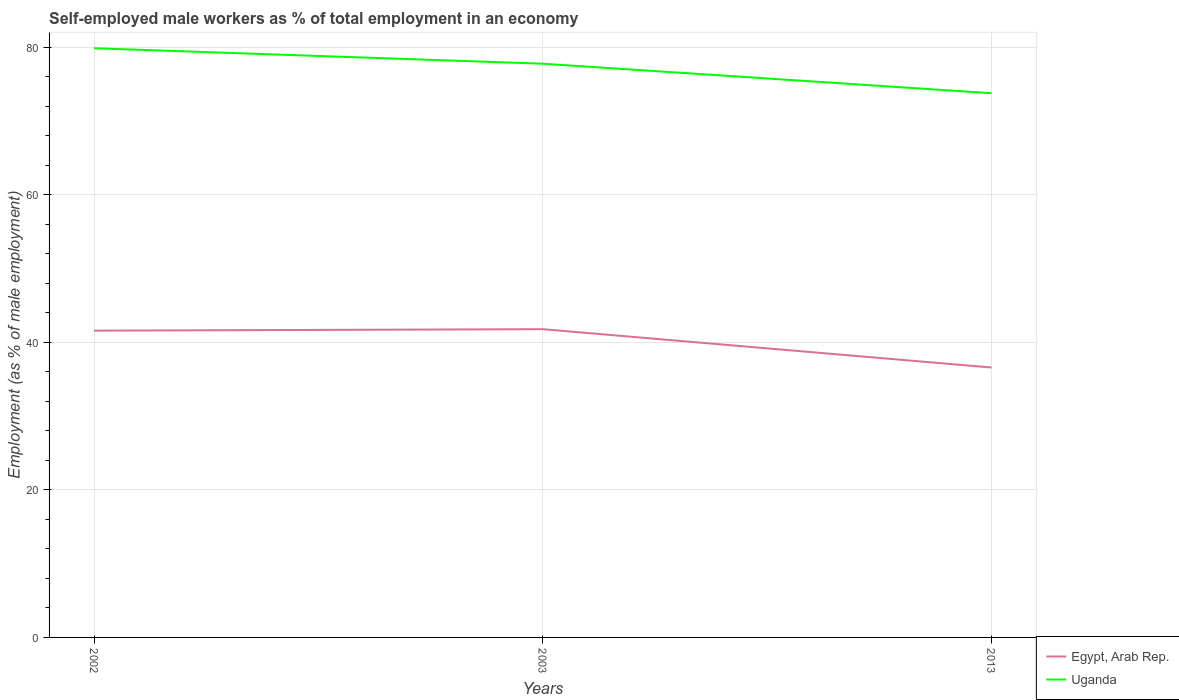Across all years, what is the maximum percentage of self-employed male workers in Egypt, Arab Rep.?
Your answer should be compact. 36.6. In which year was the percentage of self-employed male workers in Uganda maximum?
Keep it short and to the point. 2013. What is the total percentage of self-employed male workers in Egypt, Arab Rep. in the graph?
Give a very brief answer. -0.2. What is the difference between the highest and the second highest percentage of self-employed male workers in Egypt, Arab Rep.?
Your answer should be very brief. 5.2. What is the difference between the highest and the lowest percentage of self-employed male workers in Egypt, Arab Rep.?
Offer a terse response. 2. How many lines are there?
Offer a very short reply. 2. Does the graph contain any zero values?
Your answer should be very brief. No. How many legend labels are there?
Provide a succinct answer. 2. How are the legend labels stacked?
Give a very brief answer. Vertical. What is the title of the graph?
Offer a terse response. Self-employed male workers as % of total employment in an economy. Does "Malta" appear as one of the legend labels in the graph?
Provide a succinct answer. No. What is the label or title of the X-axis?
Your answer should be compact. Years. What is the label or title of the Y-axis?
Provide a succinct answer. Employment (as % of male employment). What is the Employment (as % of male employment) of Egypt, Arab Rep. in 2002?
Your response must be concise. 41.6. What is the Employment (as % of male employment) of Uganda in 2002?
Keep it short and to the point. 79.9. What is the Employment (as % of male employment) of Egypt, Arab Rep. in 2003?
Offer a very short reply. 41.8. What is the Employment (as % of male employment) of Uganda in 2003?
Your answer should be very brief. 77.8. What is the Employment (as % of male employment) in Egypt, Arab Rep. in 2013?
Keep it short and to the point. 36.6. What is the Employment (as % of male employment) in Uganda in 2013?
Your answer should be compact. 73.8. Across all years, what is the maximum Employment (as % of male employment) of Egypt, Arab Rep.?
Provide a succinct answer. 41.8. Across all years, what is the maximum Employment (as % of male employment) of Uganda?
Ensure brevity in your answer.  79.9. Across all years, what is the minimum Employment (as % of male employment) in Egypt, Arab Rep.?
Your answer should be compact. 36.6. Across all years, what is the minimum Employment (as % of male employment) in Uganda?
Keep it short and to the point. 73.8. What is the total Employment (as % of male employment) in Egypt, Arab Rep. in the graph?
Provide a succinct answer. 120. What is the total Employment (as % of male employment) of Uganda in the graph?
Give a very brief answer. 231.5. What is the difference between the Employment (as % of male employment) in Egypt, Arab Rep. in 2002 and that in 2003?
Give a very brief answer. -0.2. What is the difference between the Employment (as % of male employment) in Uganda in 2002 and that in 2003?
Keep it short and to the point. 2.1. What is the difference between the Employment (as % of male employment) of Uganda in 2002 and that in 2013?
Give a very brief answer. 6.1. What is the difference between the Employment (as % of male employment) in Uganda in 2003 and that in 2013?
Your response must be concise. 4. What is the difference between the Employment (as % of male employment) in Egypt, Arab Rep. in 2002 and the Employment (as % of male employment) in Uganda in 2003?
Offer a terse response. -36.2. What is the difference between the Employment (as % of male employment) of Egypt, Arab Rep. in 2002 and the Employment (as % of male employment) of Uganda in 2013?
Give a very brief answer. -32.2. What is the difference between the Employment (as % of male employment) of Egypt, Arab Rep. in 2003 and the Employment (as % of male employment) of Uganda in 2013?
Ensure brevity in your answer.  -32. What is the average Employment (as % of male employment) of Uganda per year?
Make the answer very short. 77.17. In the year 2002, what is the difference between the Employment (as % of male employment) of Egypt, Arab Rep. and Employment (as % of male employment) of Uganda?
Ensure brevity in your answer.  -38.3. In the year 2003, what is the difference between the Employment (as % of male employment) in Egypt, Arab Rep. and Employment (as % of male employment) in Uganda?
Provide a succinct answer. -36. In the year 2013, what is the difference between the Employment (as % of male employment) in Egypt, Arab Rep. and Employment (as % of male employment) in Uganda?
Offer a terse response. -37.2. What is the ratio of the Employment (as % of male employment) in Uganda in 2002 to that in 2003?
Ensure brevity in your answer.  1.03. What is the ratio of the Employment (as % of male employment) of Egypt, Arab Rep. in 2002 to that in 2013?
Offer a very short reply. 1.14. What is the ratio of the Employment (as % of male employment) of Uganda in 2002 to that in 2013?
Give a very brief answer. 1.08. What is the ratio of the Employment (as % of male employment) of Egypt, Arab Rep. in 2003 to that in 2013?
Provide a short and direct response. 1.14. What is the ratio of the Employment (as % of male employment) of Uganda in 2003 to that in 2013?
Your answer should be very brief. 1.05. What is the difference between the highest and the second highest Employment (as % of male employment) in Uganda?
Ensure brevity in your answer.  2.1. What is the difference between the highest and the lowest Employment (as % of male employment) of Egypt, Arab Rep.?
Offer a terse response. 5.2. 